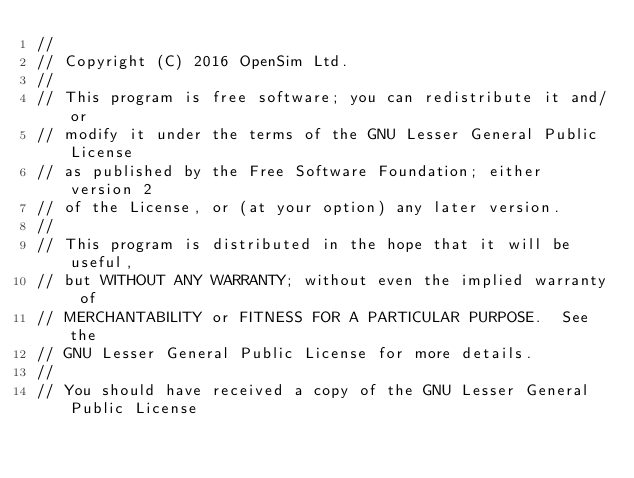<code> <loc_0><loc_0><loc_500><loc_500><_C++_>//
// Copyright (C) 2016 OpenSim Ltd.
//
// This program is free software; you can redistribute it and/or
// modify it under the terms of the GNU Lesser General Public License
// as published by the Free Software Foundation; either version 2
// of the License, or (at your option) any later version.
//
// This program is distributed in the hope that it will be useful,
// but WITHOUT ANY WARRANTY; without even the implied warranty of
// MERCHANTABILITY or FITNESS FOR A PARTICULAR PURPOSE.  See the
// GNU Lesser General Public License for more details.
//
// You should have received a copy of the GNU Lesser General Public License</code> 